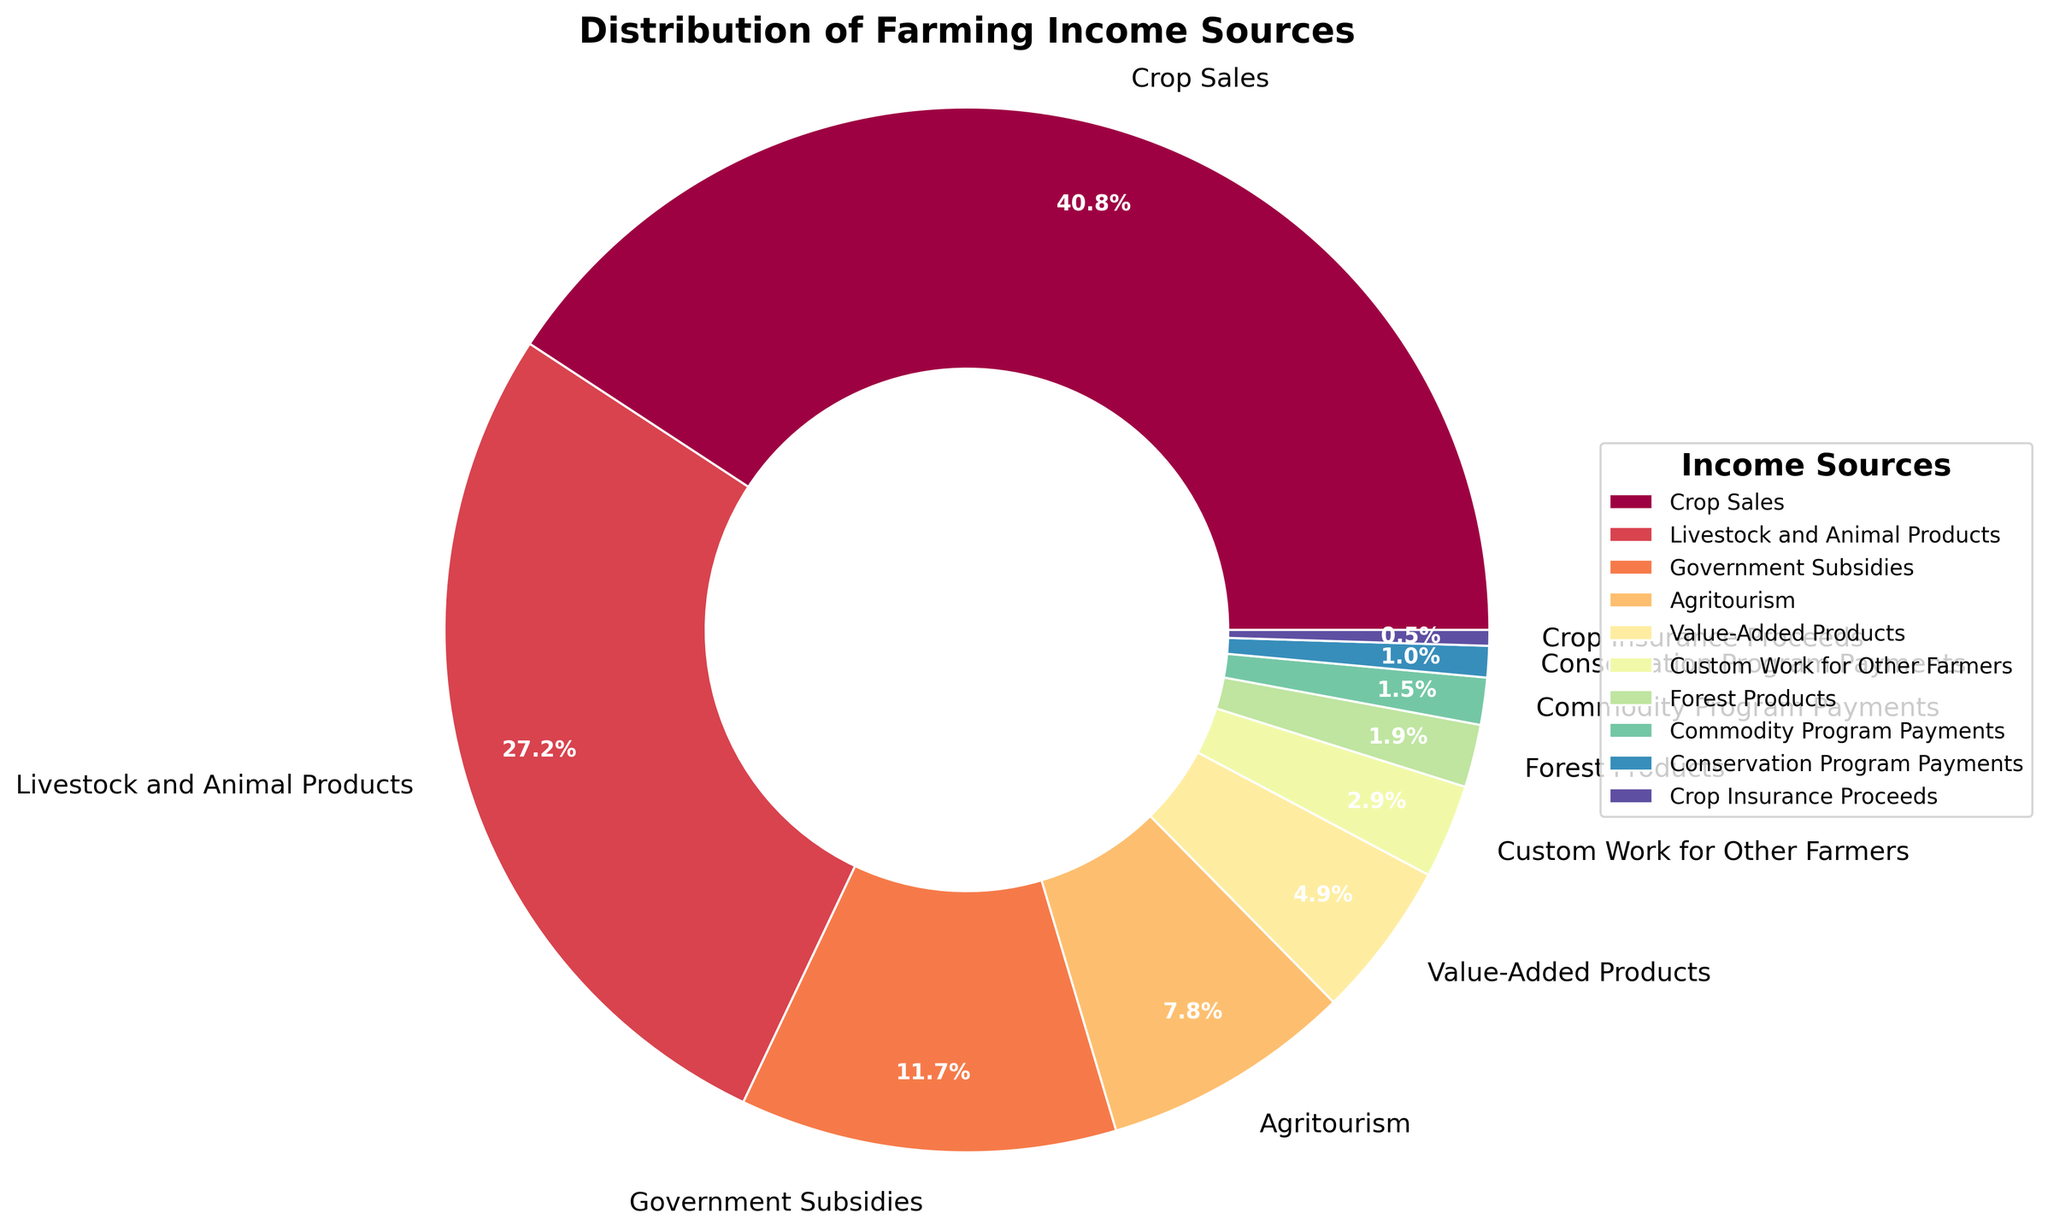What is the largest income source for farmers as shown in the pie chart? The figure shows a pie chart with different income sources labeled. By looking at the sizes of the wedges, we can see that "Crop Sales" is the largest segment.
Answer: Crop Sales What percentage of farming income comes from Value-Added Products? The pie chart includes labels with percentages for each income source. The label for Value-Added Products shows 5%.
Answer: 5% How much larger is the income percentage from Livestock and Animal Products compared to Agritourism? The pie chart indicates that Livestock and Animal Products constitute 28% of the income, while Agritourism constitutes 8%. So, the difference is 28 - 8 = 20.
Answer: 20% Which income sources collectively make up more than half of the total farming income? From the pie chart, Crop Sales is 42% and Livestock and Animal Products is 28%. Together they make 42 + 28 = 70%, which is more than half of the total.
Answer: Crop Sales and Livestock and Animal Products What is the combined percentage for income from Government Subsidies and Conservation Program Payments? The labels on the pie chart indicate 12% for Government Subsidies and 1% for Conservation Program Payments. Combined, these make 12 + 1 = 13%.
Answer: 13% Compare the income from Custom Work to that from Crop Insurance Proceeds. The pie chart shows that Custom Work for Other Farmers constitutes 3% of the income, while Crop Insurance Proceeds constitute 0.5%. 3% is significantly larger than 0.5%.
Answer: Custom Work is larger Which segment has the smallest contribution to farming income? The pie chart has a labeled segment showing Crop Insurance Proceeds with the smallest percentage, which is 0.5%.
Answer: Crop Insurance Proceeds How do Government Subsidies compare to Forest Products in terms of income contribution? The pie chart indicates that Government Subsidies contribute 12% whereas Forest Products contribute 2%. Government Subsidies contribute more.
Answer: Government Subsidies are greater What is the average percentage of income contributed by Agritourism and Value-Added Products? The pie chart shows Agritourism at 8% and Value-Added Products at 5%. The average would be (8 + 5) / 2 = 6.5%.
Answer: 6.5% Which income sources are visually represented with similarly sized segments and are closest in percentage? The pie chart shows that Custom Work for Other Farmers (3%) and Forest Products (2%) are visually similar and closest in percentage.
Answer: Custom Work for Other Farmers and Forest Products 